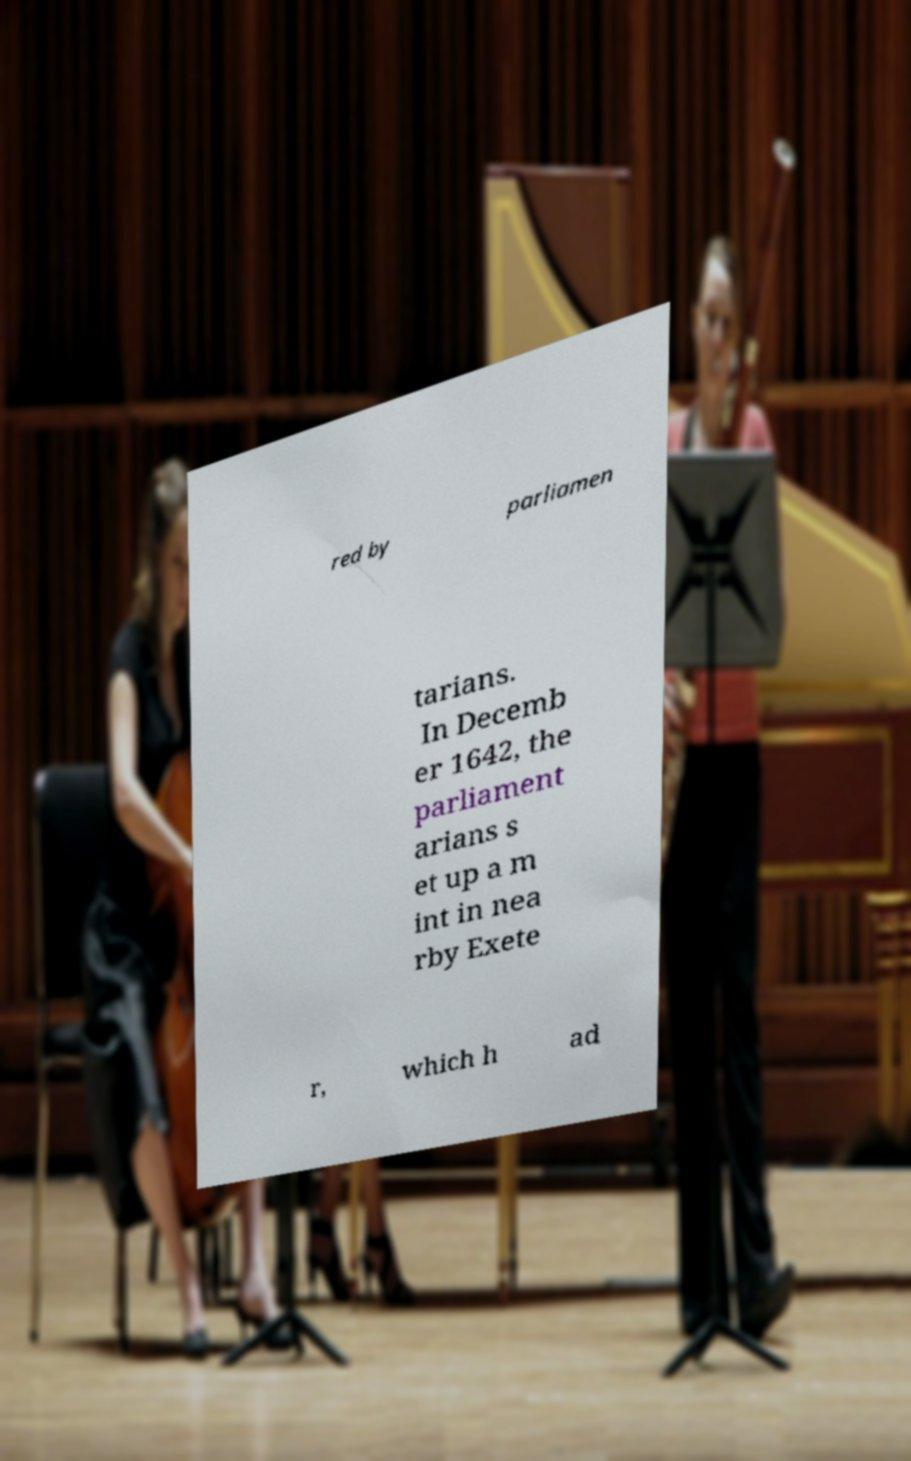Please identify and transcribe the text found in this image. red by parliamen tarians. In Decemb er 1642, the parliament arians s et up a m int in nea rby Exete r, which h ad 